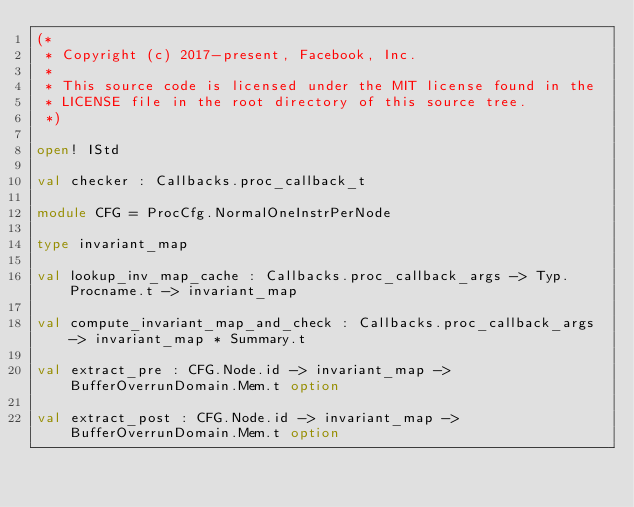<code> <loc_0><loc_0><loc_500><loc_500><_OCaml_>(*
 * Copyright (c) 2017-present, Facebook, Inc.
 *
 * This source code is licensed under the MIT license found in the
 * LICENSE file in the root directory of this source tree.
 *)

open! IStd

val checker : Callbacks.proc_callback_t

module CFG = ProcCfg.NormalOneInstrPerNode

type invariant_map

val lookup_inv_map_cache : Callbacks.proc_callback_args -> Typ.Procname.t -> invariant_map

val compute_invariant_map_and_check : Callbacks.proc_callback_args -> invariant_map * Summary.t

val extract_pre : CFG.Node.id -> invariant_map -> BufferOverrunDomain.Mem.t option

val extract_post : CFG.Node.id -> invariant_map -> BufferOverrunDomain.Mem.t option
</code> 